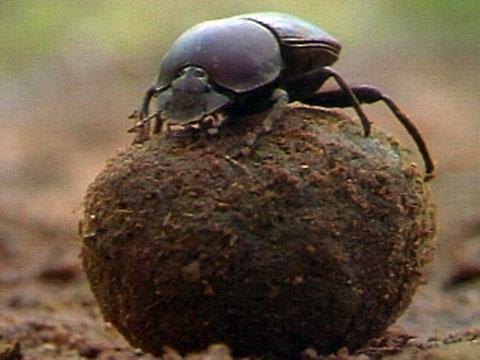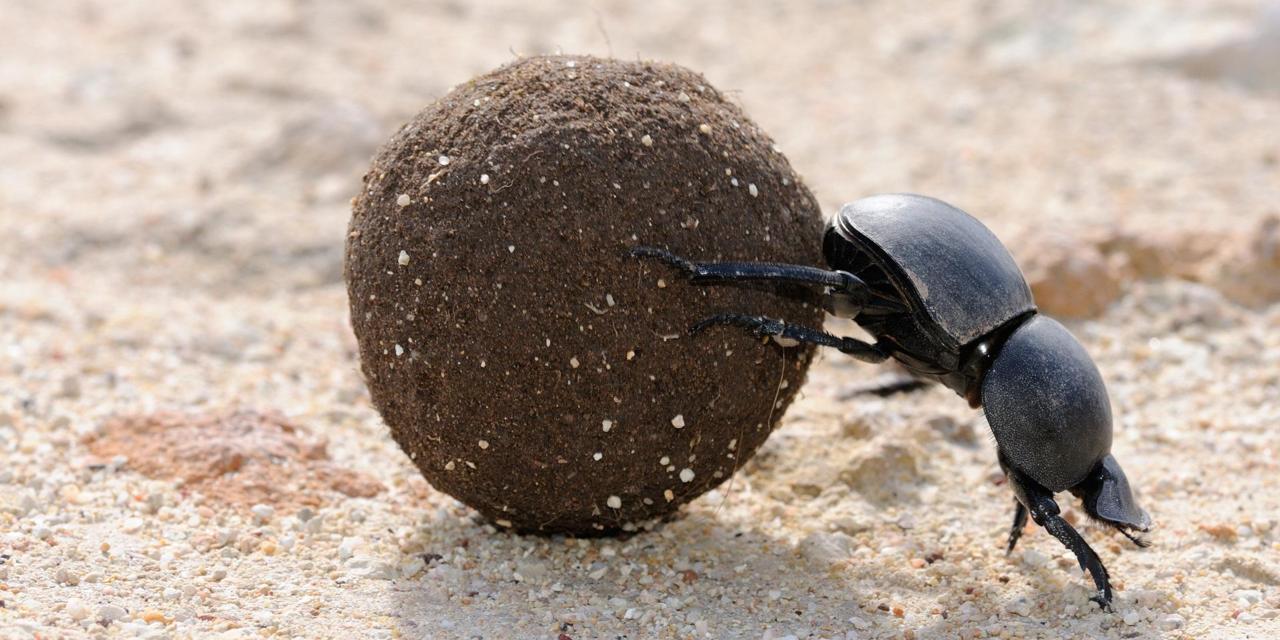The first image is the image on the left, the second image is the image on the right. Examine the images to the left and right. Is the description "In one of the image a dung beetle is on top of the dung ball." accurate? Answer yes or no. Yes. The first image is the image on the left, the second image is the image on the right. Examine the images to the left and right. Is the description "One dung beetle does not have a single limb touching the ground." accurate? Answer yes or no. Yes. 